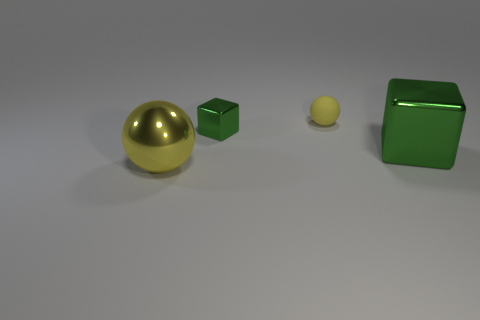Is there anything else that has the same material as the small yellow object?
Your response must be concise. No. Are the yellow ball to the left of the tiny cube and the small green thing made of the same material?
Keep it short and to the point. Yes. There is a big shiny object that is on the left side of the big shiny thing that is on the right side of the yellow ball left of the small green cube; what shape is it?
Make the answer very short. Sphere. Is there a matte cylinder that has the same size as the rubber ball?
Offer a very short reply. No. The yellow metal ball has what size?
Your answer should be very brief. Large. How many yellow metal objects are the same size as the yellow matte ball?
Make the answer very short. 0. Is the number of tiny things in front of the large green block less than the number of tiny rubber balls to the left of the small green thing?
Provide a short and direct response. No. There is a sphere on the right side of the big yellow object that is in front of the small object to the right of the small shiny block; what is its size?
Keep it short and to the point. Small. What size is the object that is right of the tiny metal object and in front of the yellow matte ball?
Your response must be concise. Large. There is a metal thing to the right of the small green object that is behind the big green metal cube; what is its shape?
Give a very brief answer. Cube. 